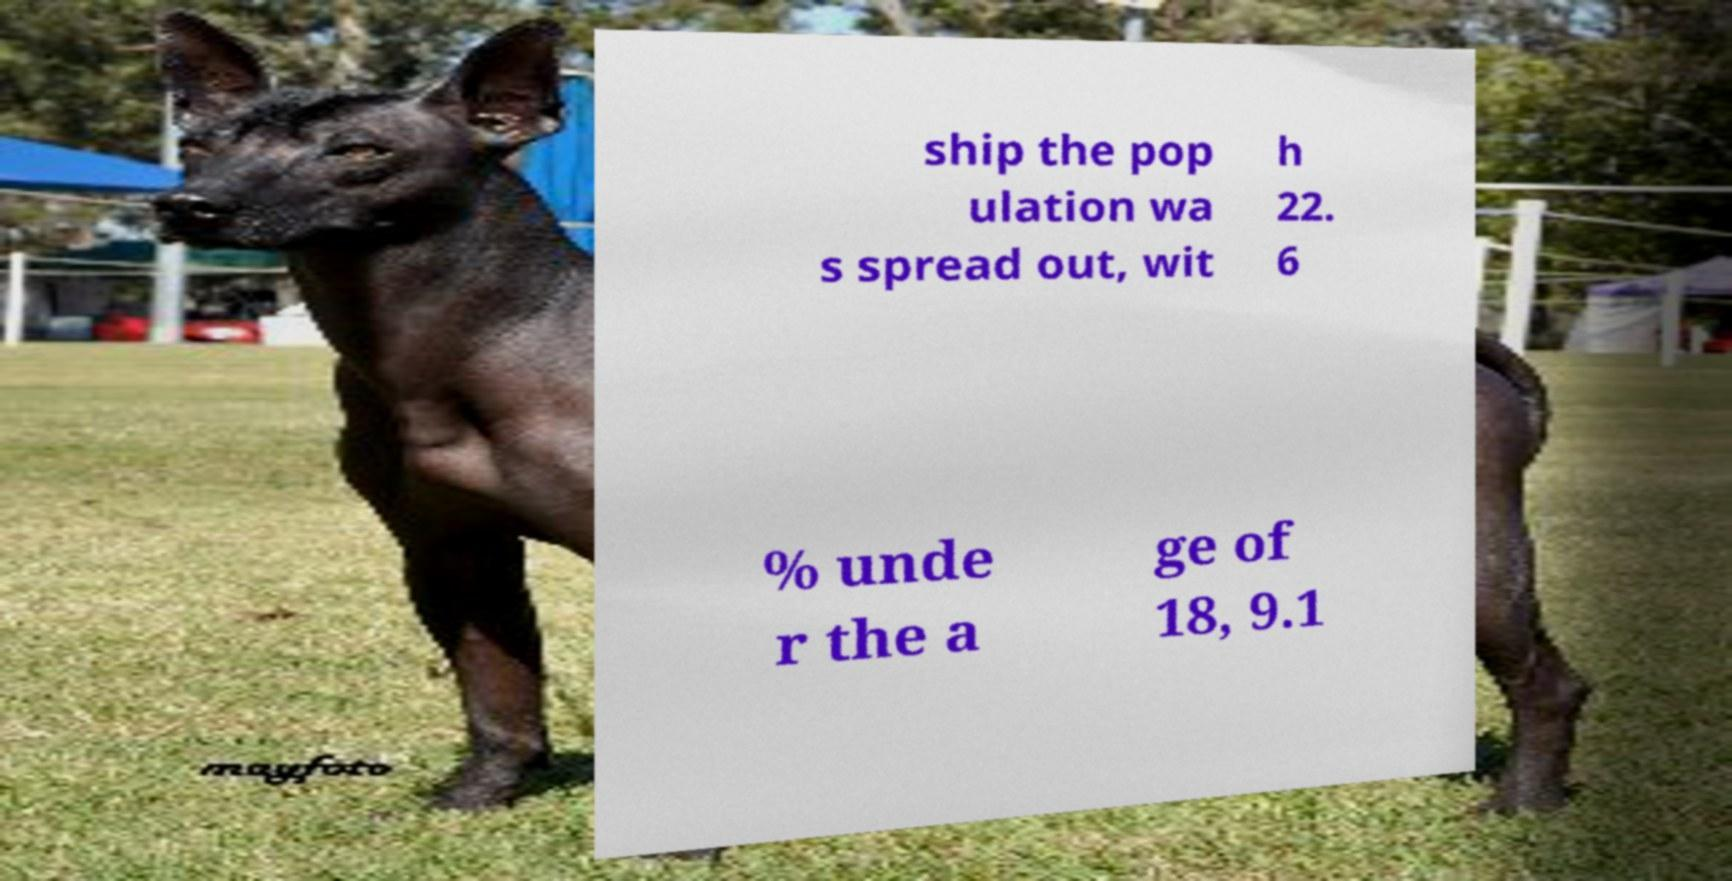Please identify and transcribe the text found in this image. ship the pop ulation wa s spread out, wit h 22. 6 % unde r the a ge of 18, 9.1 